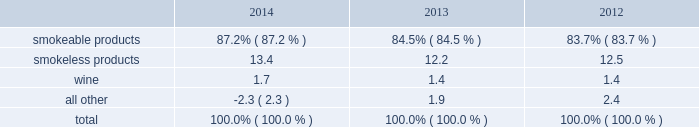Part i item 1 .
Business .
General development of business general : altria group , inc .
Is a holding company incorporated in the commonwealth of virginia in 1985 .
At december 31 , 2014 , altria group , inc . 2019s wholly-owned subsidiaries included philip morris usa inc .
( 201cpm usa 201d ) , which is engaged predominantly in the manufacture and sale of cigarettes in the united states ; john middleton co .
( 201cmiddleton 201d ) , which is engaged in the manufacture and sale of machine-made large cigars and pipe tobacco , and is a wholly- owned subsidiary of pm usa ; and ust llc ( 201cust 201d ) , which through its wholly-owned subsidiaries , including u.s .
Smokeless tobacco company llc ( 201cusstc 201d ) and ste .
Michelle wine estates ltd .
( 201cste .
Michelle 201d ) , is engaged in the manufacture and sale of smokeless tobacco products and wine .
Altria group , inc . 2019s other operating companies included nu mark llc ( 201cnu mark 201d ) , a wholly-owned subsidiary that is engaged in the manufacture and sale of innovative tobacco products , and philip morris capital corporation ( 201cpmcc 201d ) , a wholly-owned subsidiary that maintains a portfolio of finance assets , substantially all of which are leveraged leases .
Other altria group , inc .
Wholly-owned subsidiaries included altria group distribution company , which provides sales , distribution and consumer engagement services to certain altria group , inc .
Operating subsidiaries , and altria client services inc. , which provides various support services , such as legal , regulatory , finance , human resources and external affairs , to altria group , inc .
And its subsidiaries .
At december 31 , 2014 , altria group , inc .
Also held approximately 27% ( 27 % ) of the economic and voting interest of sabmiller plc ( 201csabmiller 201d ) , which altria group , inc .
Accounts for under the equity method of accounting .
Source of funds : because altria group , inc .
Is a holding company , its access to the operating cash flows of its wholly- owned subsidiaries consists of cash received from the payment of dividends and distributions , and the payment of interest on intercompany loans by its subsidiaries .
At december 31 , 2014 , altria group , inc . 2019s principal wholly-owned subsidiaries were not limited by long-term debt or other agreements in their ability to pay cash dividends or make other distributions with respect to their equity interests .
In addition , altria group , inc .
Receives cash dividends on its interest in sabmiller if and when sabmiller pays such dividends .
Financial information about segments altria group , inc . 2019s reportable segments are smokeable products , smokeless products and wine .
The financial services and the innovative tobacco products businesses are included in an all other category due to the continued reduction of the lease portfolio of pmcc and the relative financial contribution of altria group , inc . 2019s innovative tobacco products businesses to altria group , inc . 2019s consolidated results .
Altria group , inc . 2019s chief operating decision maker reviews operating companies income to evaluate the performance of , and allocate resources to , the segments .
Operating companies income for the segments is defined as operating income before amortization of intangibles and general corporate expenses .
Interest and other debt expense , net , and provision for income taxes are centrally managed at the corporate level and , accordingly , such items are not presented by segment since they are excluded from the measure of segment profitability reviewed by altria group , inc . 2019s chief operating decision maker .
Net revenues and operating companies income ( together with a reconciliation to earnings before income taxes ) attributable to each such segment for each of the last three years are set forth in note 15 .
Segment reporting to the consolidated financial statements in item 8 .
Financial statements and supplementary data of this annual report on form 10-k ( 201citem 8 201d ) .
Information about total assets by segment is not disclosed because such information is not reported to or used by altria group , inc . 2019s chief operating decision maker .
Segment goodwill and other intangible assets , net , are disclosed in note 4 .
Goodwill and other intangible assets , net to the consolidated financial statements in item 8 ( 201cnote 4 201d ) .
The accounting policies of the segments are the same as those described in note 2 .
Summary of significant accounting policies to the consolidated financial statements in item 8 ( 201cnote 2 201d ) .
The relative percentages of operating companies income ( loss ) attributable to each reportable segment and the all other category were as follows: .
For items affecting the comparability of the relative percentages of operating companies income ( loss ) attributable to each reportable segment , see note 15 .
Segment reporting to the consolidated financial statements in item 8 ( 201cnote 15 201d ) .
Narrative description of business portions of the information called for by this item are included in item 7 .
Management 2019s discussion and analysis of financial condition and results of operations - operating results by business segment of this annual report on form 10-k .
Tobacco space altria group , inc . 2019s tobacco operating companies include pm usa , usstc and other subsidiaries of ust , middleton and nu mark .
Altria group distribution company provides sales , distribution and consumer engagement services to altria group , inc . 2019s tobacco operating companies .
The products of altria group , inc . 2019s tobacco subsidiaries include smokeable tobacco products comprised of cigarettes manufactured and sold by pm usa and machine-made large altria_mdc_2014form10k_nolinks_crops.pdf 3 2/25/15 5:56 pm .
What is the percent change in the relative percentages of operating companies income ( loss ) attributable to smokeless products from 2013 to 2014? 
Computations: (13.4 - 12.2)
Answer: 1.2. 